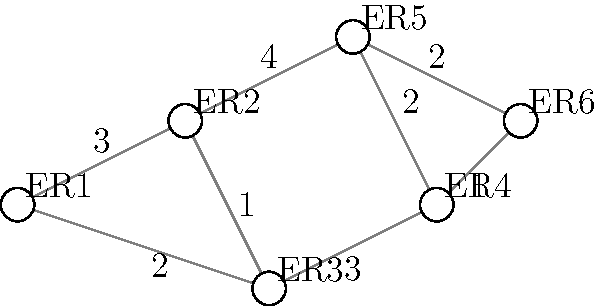In a city with six emergency rooms (ER1 to ER6) connected as shown in the graph, where the numbers on the edges represent travel time in minutes, what is the shortest time required to travel from ER1 to ER6? To find the shortest path from ER1 to ER6, we need to consider all possible routes and their total travel times:

1. ER1 → ER2 → ER5 → ER6: 3 + 4 + 2 = 9 minutes
2. ER1 → ER2 → ER3 → ER4 → ER6: 3 + 1 + 3 + 1 = 8 minutes
3. ER1 → ER3 → ER4 → ER6: 2 + 3 + 1 = 6 minutes

The shortest path is ER1 → ER3 → ER4 → ER6, which takes 6 minutes.

This can be verified using Dijkstra's algorithm or other shortest path algorithms, but for this small graph, we can easily check all possible routes manually.
Answer: 6 minutes 